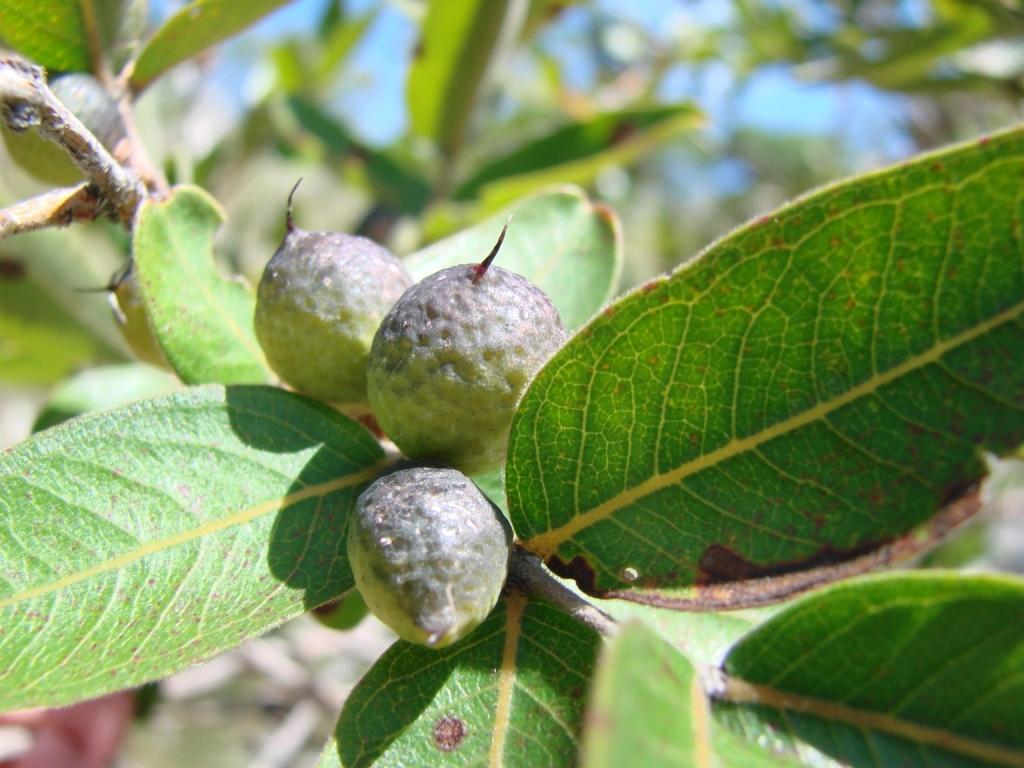What type of food items can be seen in the image? There are fruits in the image. What color are the leaves associated with the fruits? The leaves in the image are green. How are the fruits colored in the image? The fruits are in grey color. What can be seen in the background of the image? There is a sky visible in the background of the image. How many girls are present in the image? There are no girls present in the image; it features fruits and leaves. What type of achievement is being celebrated in the image? There is no achievement being celebrated in the image; it is a still life of fruits and leaves. 